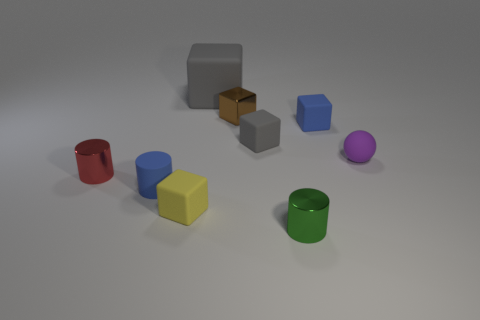Subtract all small gray matte cubes. How many cubes are left? 4 Subtract 5 cubes. How many cubes are left? 0 Add 1 red rubber things. How many objects exist? 10 Subtract all green cylinders. How many cylinders are left? 2 Subtract all balls. How many objects are left? 8 Subtract all red cubes. Subtract all purple balls. How many cubes are left? 5 Subtract all yellow balls. How many yellow cylinders are left? 0 Subtract all brown blocks. Subtract all cubes. How many objects are left? 3 Add 9 small gray rubber cubes. How many small gray rubber cubes are left? 10 Add 8 tiny cyan spheres. How many tiny cyan spheres exist? 8 